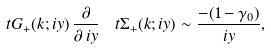<formula> <loc_0><loc_0><loc_500><loc_500>\ t { G } _ { + } ( k ; i y ) \, \frac { \partial } { \partial \, i y } \, \ t { \Sigma } _ { + } ( k ; i y ) \sim \frac { - ( 1 - \gamma _ { 0 } ) } { i y } ,</formula> 